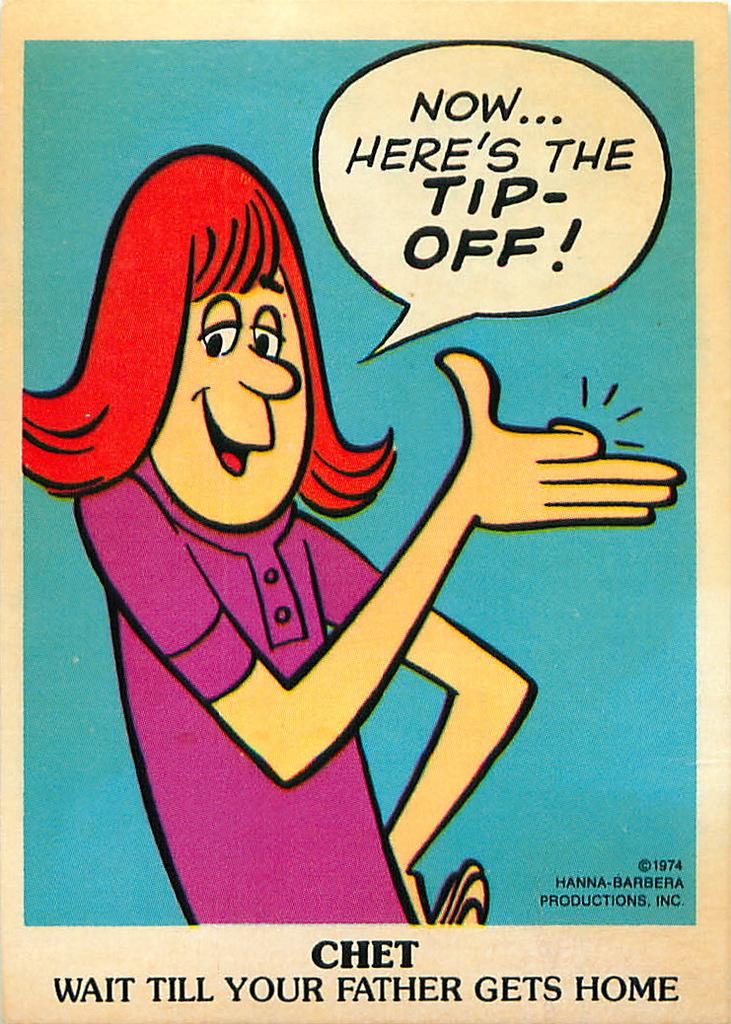<image>
Provide a brief description of the given image. A women cartoon with red hair and a purple shirt saying Now... Here's the Tip-off. 